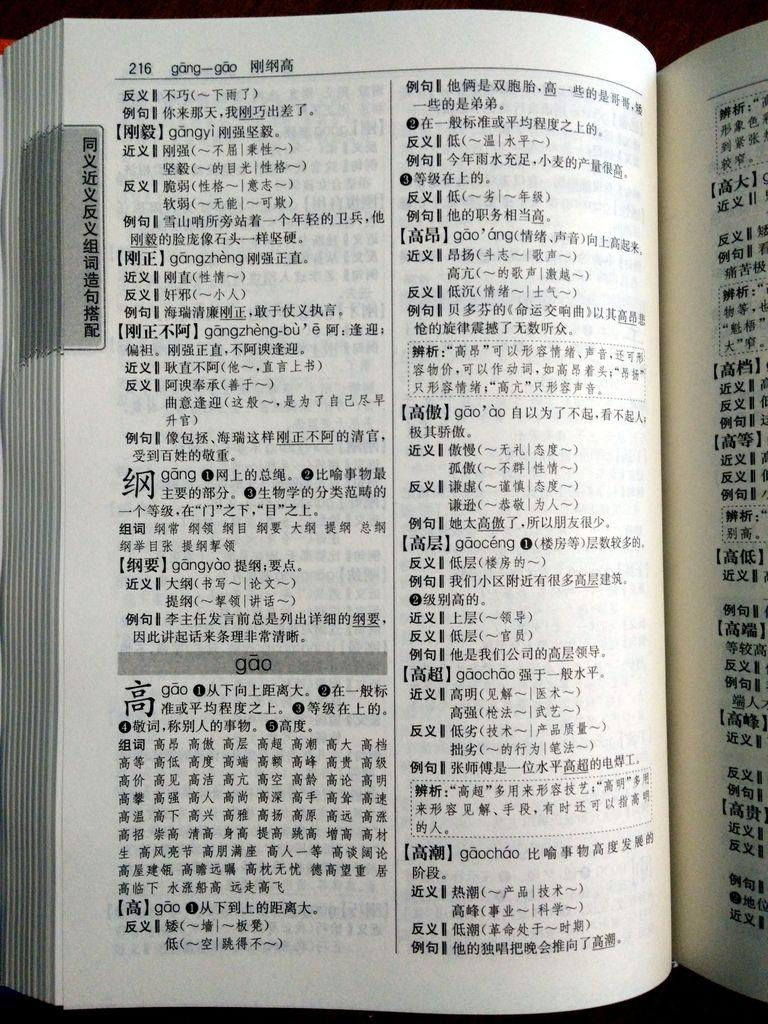Provide a one-sentence caption for the provided image. A book in an Asian language is opened to page 216 with the heading "gang-gao.". 